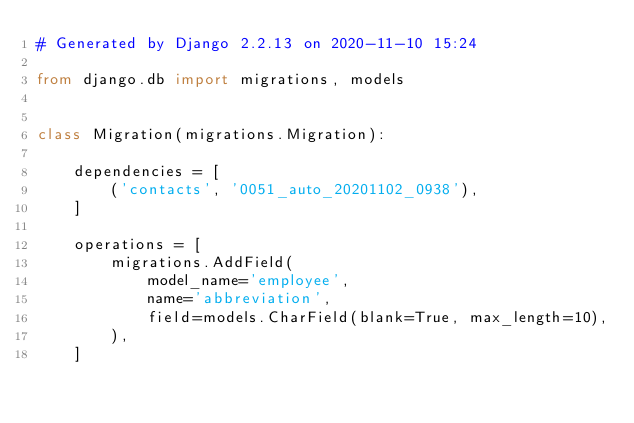<code> <loc_0><loc_0><loc_500><loc_500><_Python_># Generated by Django 2.2.13 on 2020-11-10 15:24

from django.db import migrations, models


class Migration(migrations.Migration):

    dependencies = [
        ('contacts', '0051_auto_20201102_0938'),
    ]

    operations = [
        migrations.AddField(
            model_name='employee',
            name='abbreviation',
            field=models.CharField(blank=True, max_length=10),
        ),
    ]
</code> 